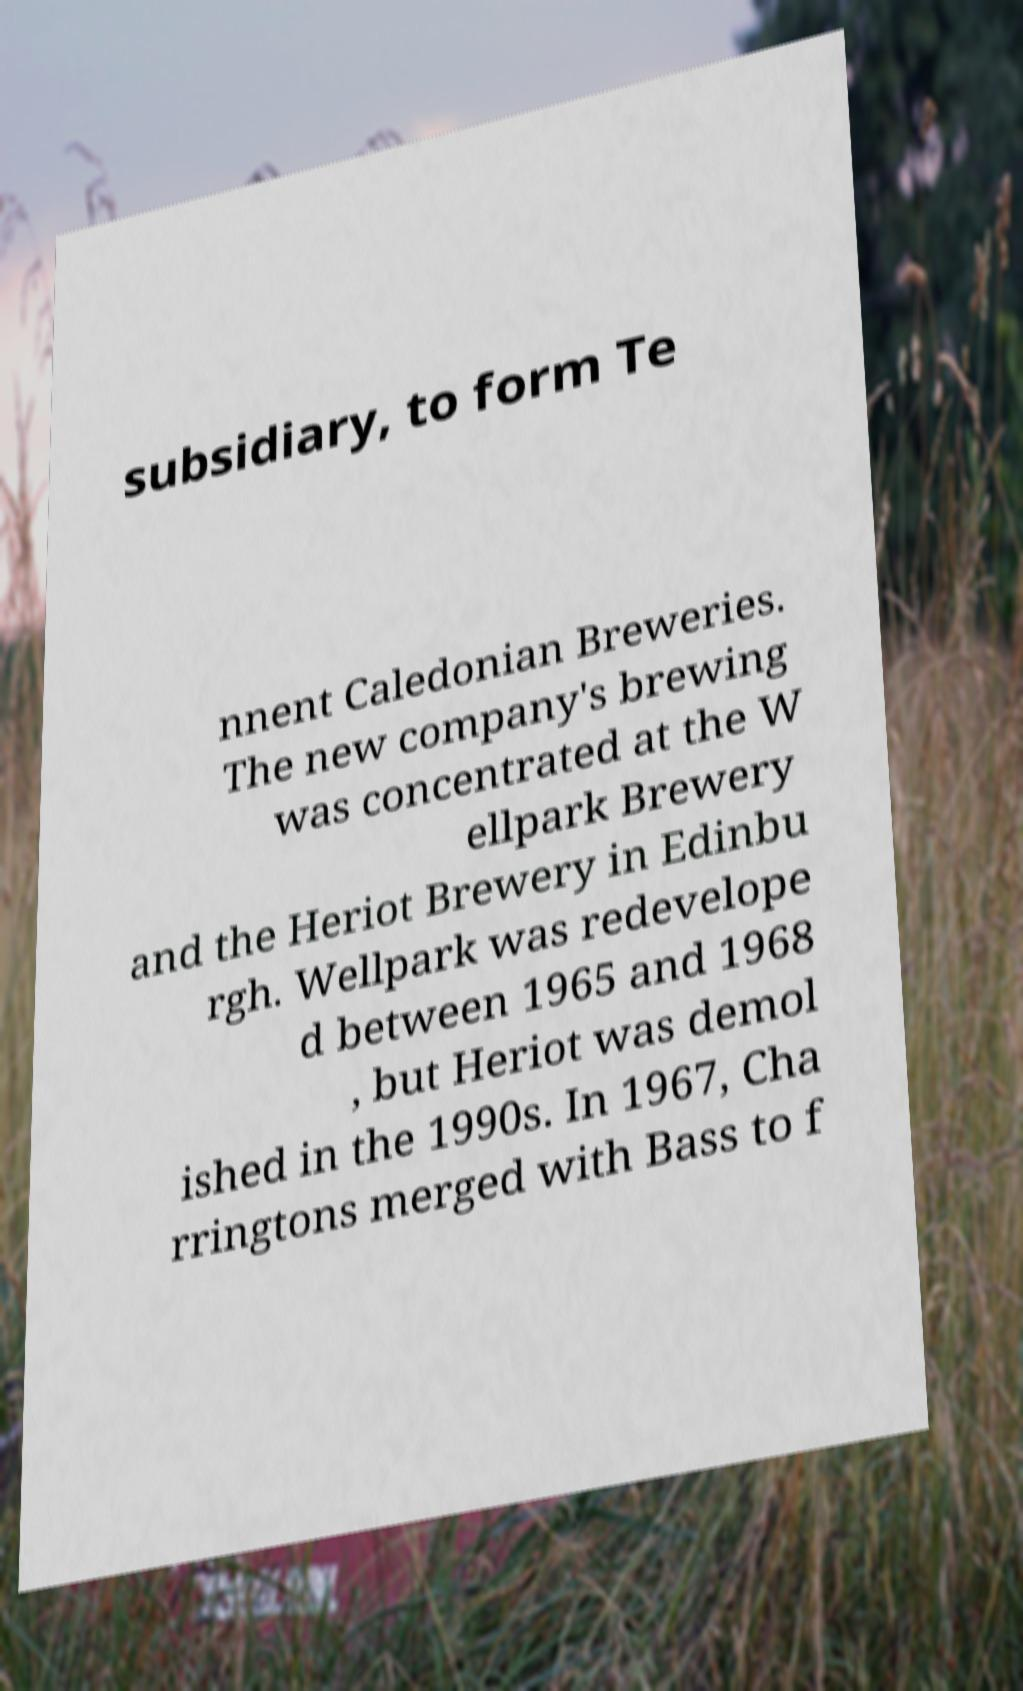Please identify and transcribe the text found in this image. subsidiary, to form Te nnent Caledonian Breweries. The new company's brewing was concentrated at the W ellpark Brewery and the Heriot Brewery in Edinbu rgh. Wellpark was redevelope d between 1965 and 1968 , but Heriot was demol ished in the 1990s. In 1967, Cha rringtons merged with Bass to f 